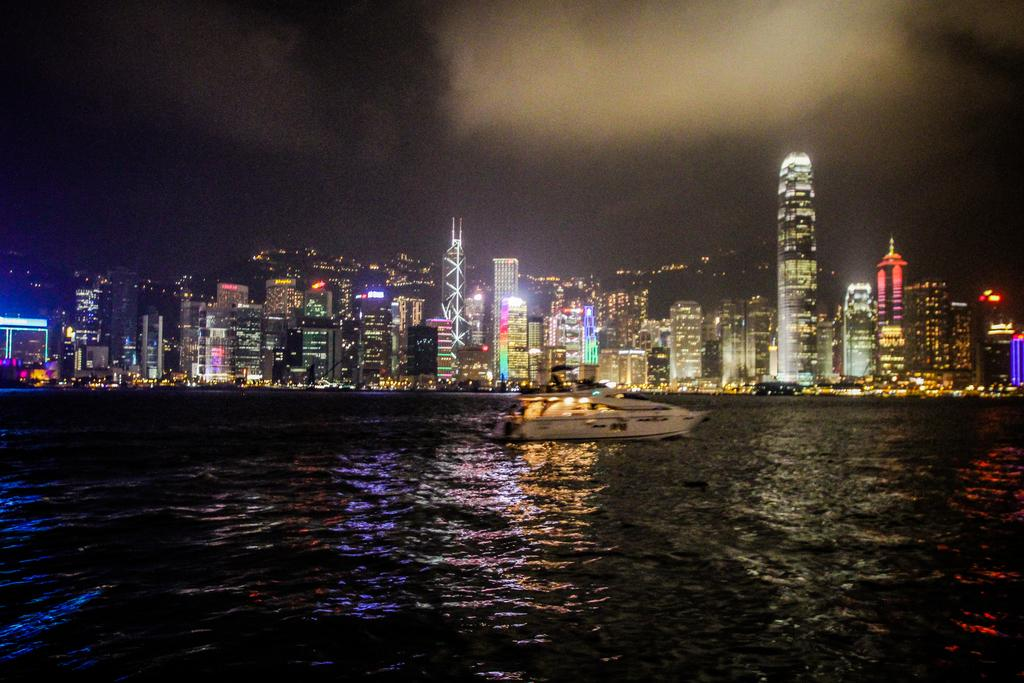What is the lighting condition in the image? The image is taken in night mode. What can be seen in the background of the image? There are many buildings with lightning in the background. What is visible at the top of the image? The sky is visible at the top of the image. What type of weather condition can be inferred from the image? Clouds are present in the sky, suggesting a possible weather condition. How many eyes can be seen on the buildings in the image? There are no eyes visible on the buildings in the image. What day of the week is depicted in the image? The image does not depict a specific day of the week. 